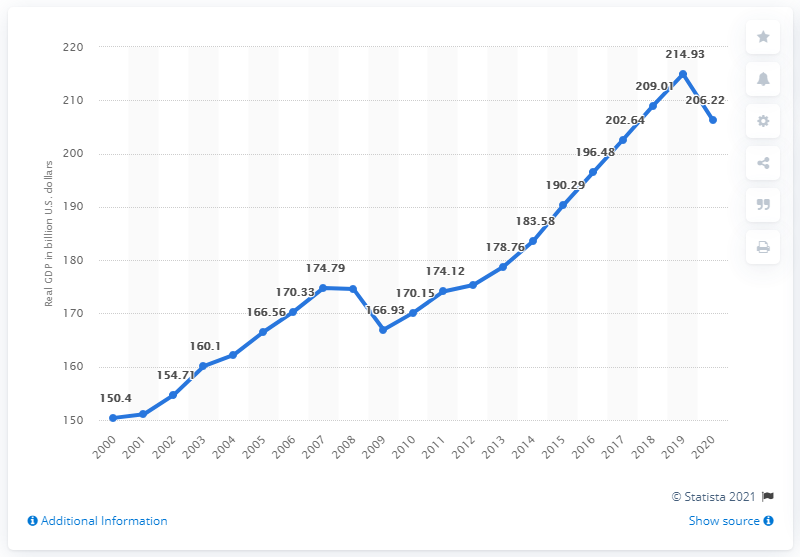List a handful of essential elements in this visual. The previous real GDP of South Carolina was 214.93. The real GDP of South Carolina in 2020 was 206.22. 